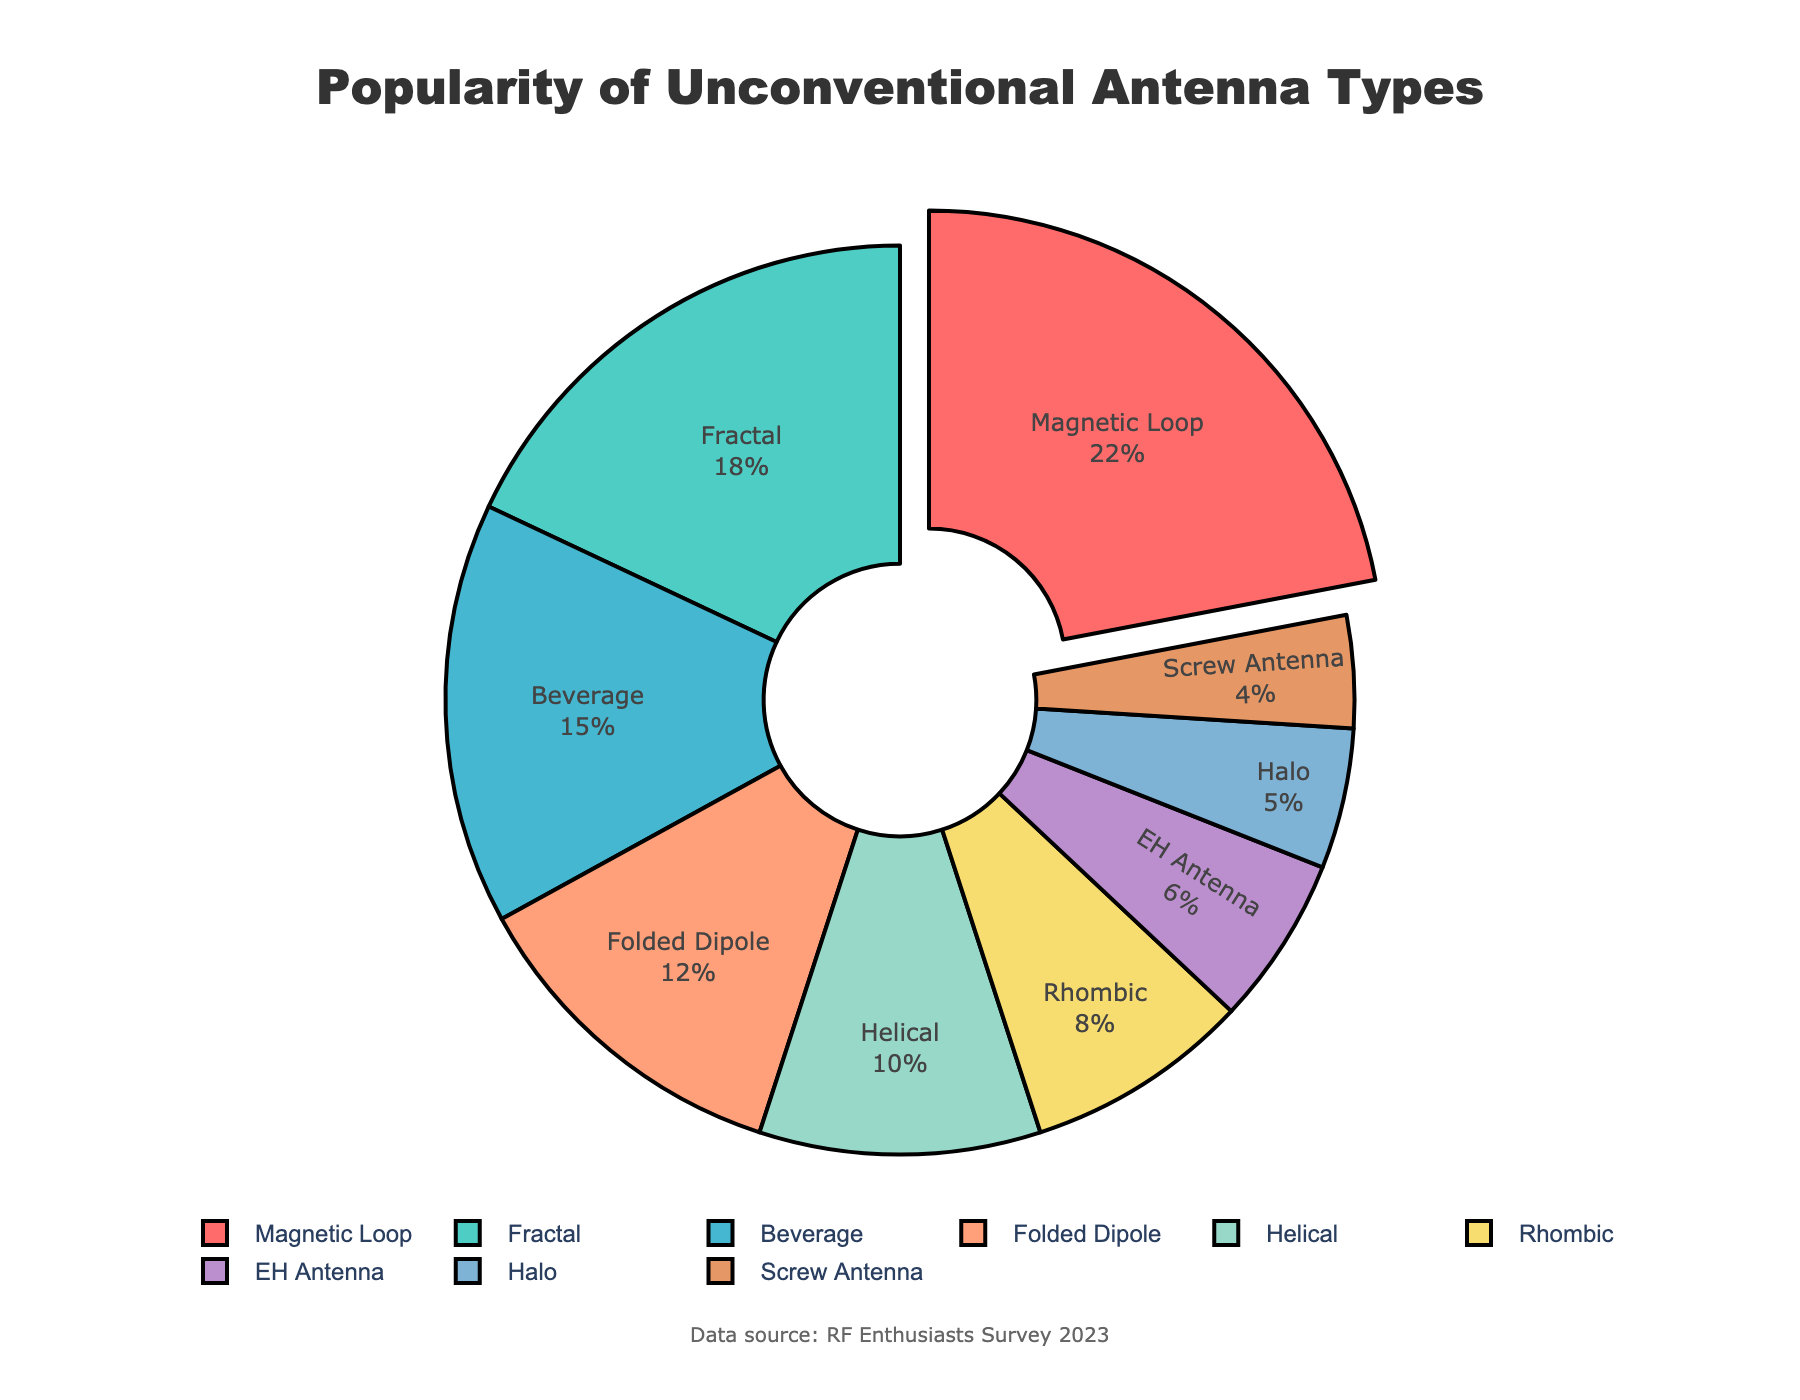What's the most popular antenna type among RF enthusiasts? Look at the pie chart and identify the segment that is slightly separated (pulled out) from the rest. This indicates the most popular antenna type. In this case, it's the "Magnetic Loop" with 22% of the share.
Answer: Magnetic Loop Which antenna type has a popularity percentage closest to the average percentage of all listed antenna types? Calculate the average percentage by summing up all percentages and dividing by the number of antenna types: \( \frac{22 + 18 + 15 + 12 + 10 + 8 + 6 + 5 + 4}{9} = 11.11 \). The closest percentage to this average is 10%, which corresponds to the Helical antenna.
Answer: Helical How much more popular is the "Magnetic Loop" antenna compared to the "Fractal" antenna? The popularity percentage of the "Magnetic Loop" is 22%, and for "Fractal" it is 18%. Subtract the two values: \( 22 - 18 = 4 \). Therefore, the "Magnetic Loop" antenna is 4% more popular than the "Fractal" antenna.
Answer: 4% What is the combined popularity percentage of the top three most popular antenna types? Identify the top three percentages: Magnetic Loop (22%), Fractal (18%), and Beverage (15%). Sum these values: \( 22 + 18 + 15 = 55 \). The combined popularity percentage is 55%.
Answer: 55% Which antenna types have a combined popularity of less than 10% each? Check the pie chart for percentages less than 10%: Rhombic (8%), EH Antenna (6%), Halo (5%), and Screw Antenna (4%).
Answer: Rhombic, EH Antenna, Halo, Screw Antenna What is the difference in popularity between the "Beverage" and the "Rhombic" antennas? The popularity percentage for "Beverage" is 15% and for "Rhombic" is 8%. Subtract the smaller percentage from the larger one: \( 15 - 8 = 7 \). The difference in popularity is 7%.
Answer: 7% Which colors on the pie chart correspond to the "Helical" and "Halo" antennas? Look at the specific segments for "Helical" and "Halo" antennas and identify their colors. "Helical" is represented by a brown segment and "Halo" by a dark blue segment.
Answer: Helical: brown, Halo: dark blue How does the "Folded Dipole" antenna's popularity compare relative to the total percentage of the three least popular antennas? The percentage for "Folded Dipole" is 12%. The three least popular antennas are EH Antenna (6%), Halo (5%), and Screw Antenna (4%). Sum these three: \( 6 + 5 + 4 = 15 \). Now compare: 12% vs 15%. The "Folded Dipole" has a slightly lower combined percentage.
Answer: Lower If you were to divide the antennas into "above average" and "below average" categories, which antenna types would fall into each? First, calculate the average percentage: \( \frac{22 + 18 + 15 + 12 + 10 + 8 + 6 + 5 + 4}{9} = 11.11 \). Antenna types above average include: Magnetic Loop (22%), Fractal (18%), Beverage (15%), and Folded Dipole (12%). Below average are: Helical (10%), Rhombic (8%), EH Antenna (6%), Halo (5%), and Screw Antenna (4%).
Answer: Above average: Magnetic Loop, Fractal, Beverage, Folded Dipole. Below average: Helical, Rhombic, EH Antenna, Halo, Screw Antenna What's the ratio of the popularity percentage of the most popular antenna type to the least popular antenna type? The popularity percentage of the most popular antenna, "Magnetic Loop", is 22%. The least popular antenna, "Screw Antenna", has a percentage of 4%. The ratio is \( \frac{22}{4} = 5.5 \).
Answer: 5.5 